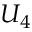<formula> <loc_0><loc_0><loc_500><loc_500>U _ { 4 }</formula> 